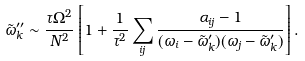Convert formula to latex. <formula><loc_0><loc_0><loc_500><loc_500>\tilde { \omega } ^ { \prime \prime } _ { k } \sim \frac { \tau \Omega ^ { 2 } } { N ^ { 2 } } \left [ 1 + \frac { 1 } { \tau ^ { 2 } } \sum _ { i j } \frac { \alpha _ { i j } - 1 } { ( \omega _ { i } - \tilde { \omega } ^ { \prime } _ { k } ) ( \omega _ { j } - \tilde { \omega } ^ { \prime } _ { k } ) } \right ] .</formula> 